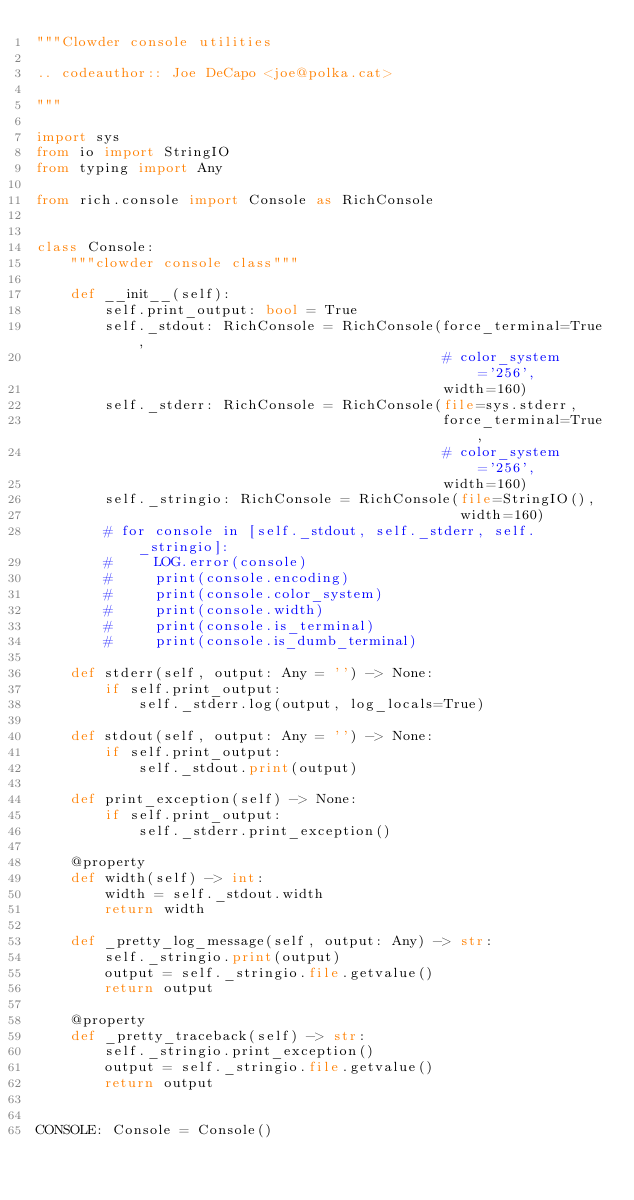Convert code to text. <code><loc_0><loc_0><loc_500><loc_500><_Python_>"""Clowder console utilities

.. codeauthor:: Joe DeCapo <joe@polka.cat>

"""

import sys
from io import StringIO
from typing import Any

from rich.console import Console as RichConsole


class Console:
    """clowder console class"""

    def __init__(self):
        self.print_output: bool = True
        self._stdout: RichConsole = RichConsole(force_terminal=True,
                                                # color_system='256',
                                                width=160)
        self._stderr: RichConsole = RichConsole(file=sys.stderr,
                                                force_terminal=True,
                                                # color_system='256',
                                                width=160)
        self._stringio: RichConsole = RichConsole(file=StringIO(),
                                                  width=160)
        # for console in [self._stdout, self._stderr, self._stringio]:
        #     LOG.error(console)
        #     print(console.encoding)
        #     print(console.color_system)
        #     print(console.width)
        #     print(console.is_terminal)
        #     print(console.is_dumb_terminal)

    def stderr(self, output: Any = '') -> None:
        if self.print_output:
            self._stderr.log(output, log_locals=True)

    def stdout(self, output: Any = '') -> None:
        if self.print_output:
            self._stdout.print(output)

    def print_exception(self) -> None:
        if self.print_output:
            self._stderr.print_exception()

    @property
    def width(self) -> int:
        width = self._stdout.width
        return width

    def _pretty_log_message(self, output: Any) -> str:
        self._stringio.print(output)
        output = self._stringio.file.getvalue()
        return output

    @property
    def _pretty_traceback(self) -> str:
        self._stringio.print_exception()
        output = self._stringio.file.getvalue()
        return output


CONSOLE: Console = Console()
</code> 